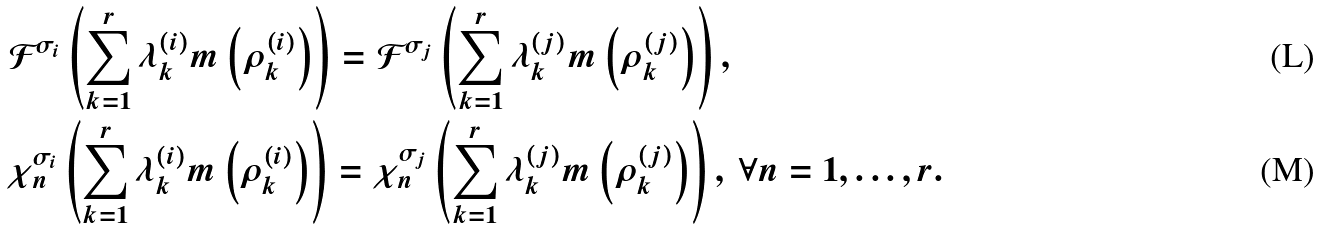<formula> <loc_0><loc_0><loc_500><loc_500>& \mathcal { F } ^ { \sigma _ { i } } \left ( \sum _ { k = 1 } ^ { r } \lambda ^ { ( i ) } _ { k } m \left ( \rho _ { k } ^ { ( i ) } \right ) \right ) = \mathcal { F } ^ { \sigma _ { j } } \left ( \sum _ { k = 1 } ^ { r } \lambda ^ { ( j ) } _ { k } m \left ( \rho _ { k } ^ { ( j ) } \right ) \right ) , \\ & \chi _ { n } ^ { \sigma _ { i } } \left ( \sum _ { k = 1 } ^ { r } \lambda ^ { ( i ) } _ { k } m \left ( \rho _ { k } ^ { ( i ) } \right ) \right ) = \chi _ { n } ^ { \sigma _ { j } } \left ( \sum _ { k = 1 } ^ { r } \lambda ^ { ( j ) } _ { k } m \left ( \rho _ { k } ^ { ( j ) } \right ) \right ) , \ \forall n = 1 , \dots , r .</formula> 